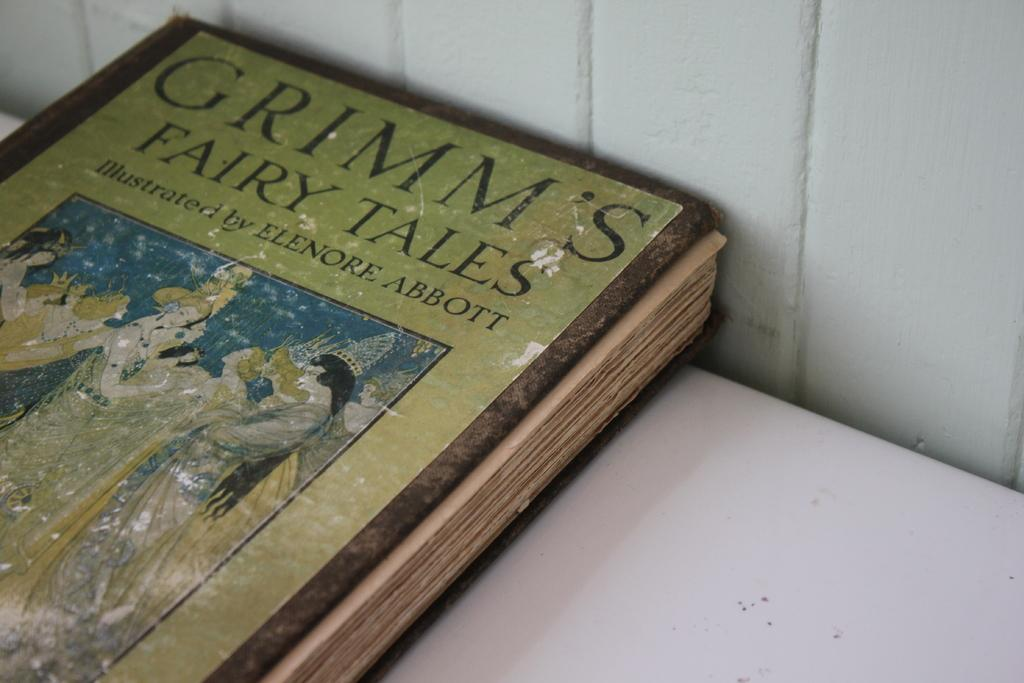Provide a one-sentence caption for the provided image. A Grimm's Fairy Tales book sitting on a white table. 